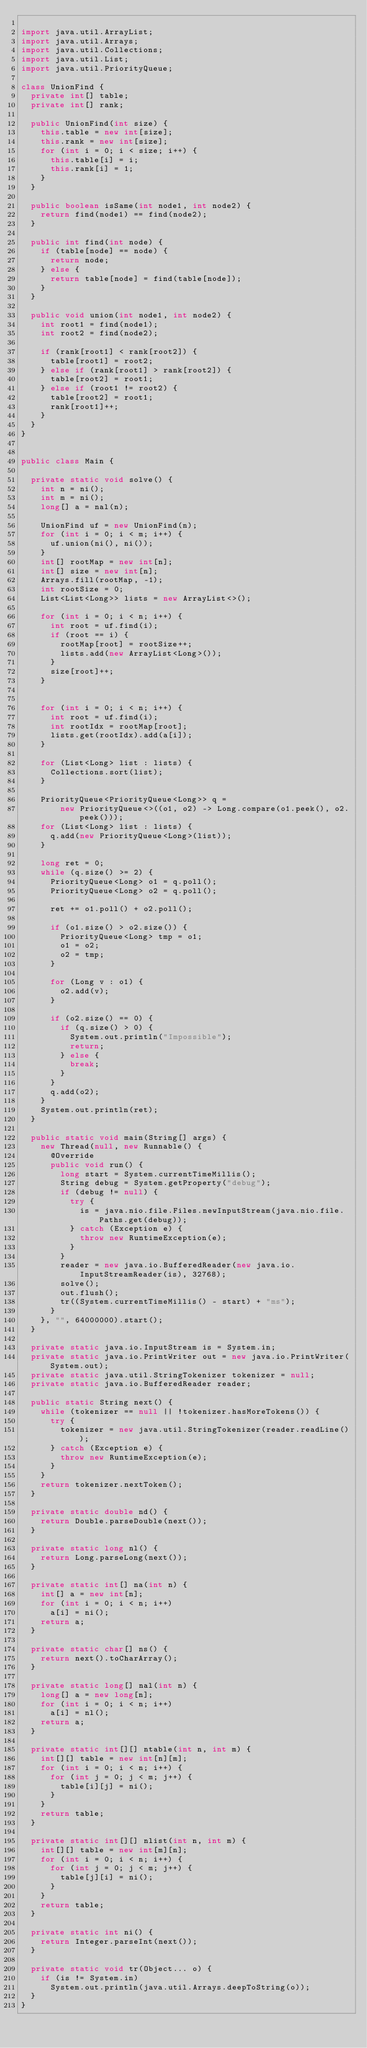<code> <loc_0><loc_0><loc_500><loc_500><_Java_>
import java.util.ArrayList;
import java.util.Arrays;
import java.util.Collections;
import java.util.List;
import java.util.PriorityQueue;

class UnionFind {
  private int[] table;
  private int[] rank;

  public UnionFind(int size) {
    this.table = new int[size];
    this.rank = new int[size];
    for (int i = 0; i < size; i++) {
      this.table[i] = i;
      this.rank[i] = 1;
    }
  }

  public boolean isSame(int node1, int node2) {
    return find(node1) == find(node2);
  }

  public int find(int node) {
    if (table[node] == node) {
      return node;
    } else {
      return table[node] = find(table[node]);
    }
  }

  public void union(int node1, int node2) {
    int root1 = find(node1);
    int root2 = find(node2);

    if (rank[root1] < rank[root2]) {
      table[root1] = root2;
    } else if (rank[root1] > rank[root2]) {
      table[root2] = root1;
    } else if (root1 != root2) {
      table[root2] = root1;
      rank[root1]++;
    }
  }
}


public class Main {

  private static void solve() {
    int n = ni();
    int m = ni();
    long[] a = nal(n);

    UnionFind uf = new UnionFind(n);
    for (int i = 0; i < m; i++) {
      uf.union(ni(), ni());
    }
    int[] rootMap = new int[n];
    int[] size = new int[n];
    Arrays.fill(rootMap, -1);
    int rootSize = 0;
    List<List<Long>> lists = new ArrayList<>();

    for (int i = 0; i < n; i++) {
      int root = uf.find(i);
      if (root == i) {
        rootMap[root] = rootSize++;
        lists.add(new ArrayList<Long>());
      }
      size[root]++;
    }


    for (int i = 0; i < n; i++) {
      int root = uf.find(i);
      int rootIdx = rootMap[root];
      lists.get(rootIdx).add(a[i]);
    }

    for (List<Long> list : lists) {
      Collections.sort(list);
    }

    PriorityQueue<PriorityQueue<Long>> q =
        new PriorityQueue<>((o1, o2) -> Long.compare(o1.peek(), o2.peek()));
    for (List<Long> list : lists) {
      q.add(new PriorityQueue<Long>(list));
    }
    
    long ret = 0;
    while (q.size() >= 2) {
      PriorityQueue<Long> o1 = q.poll();
      PriorityQueue<Long> o2 = q.poll();
      
      ret += o1.poll() + o2.poll();
      
      if (o1.size() > o2.size()) {
        PriorityQueue<Long> tmp = o1;
        o1 = o2;
        o2 = tmp;
      }

      for (Long v : o1) {
        o2.add(v);
      }
      
      if (o2.size() == 0) {
        if (q.size() > 0) {
          System.out.println("Impossible");
          return;
        } else {
          break;
        }
      }
      q.add(o2);
    }
    System.out.println(ret);
  }

  public static void main(String[] args) {
    new Thread(null, new Runnable() {
      @Override
      public void run() {
        long start = System.currentTimeMillis();
        String debug = System.getProperty("debug");
        if (debug != null) {
          try {
            is = java.nio.file.Files.newInputStream(java.nio.file.Paths.get(debug));
          } catch (Exception e) {
            throw new RuntimeException(e);
          }
        }
        reader = new java.io.BufferedReader(new java.io.InputStreamReader(is), 32768);
        solve();
        out.flush();
        tr((System.currentTimeMillis() - start) + "ms");
      }
    }, "", 64000000).start();
  }

  private static java.io.InputStream is = System.in;
  private static java.io.PrintWriter out = new java.io.PrintWriter(System.out);
  private static java.util.StringTokenizer tokenizer = null;
  private static java.io.BufferedReader reader;

  public static String next() {
    while (tokenizer == null || !tokenizer.hasMoreTokens()) {
      try {
        tokenizer = new java.util.StringTokenizer(reader.readLine());
      } catch (Exception e) {
        throw new RuntimeException(e);
      }
    }
    return tokenizer.nextToken();
  }

  private static double nd() {
    return Double.parseDouble(next());
  }

  private static long nl() {
    return Long.parseLong(next());
  }

  private static int[] na(int n) {
    int[] a = new int[n];
    for (int i = 0; i < n; i++)
      a[i] = ni();
    return a;
  }

  private static char[] ns() {
    return next().toCharArray();
  }

  private static long[] nal(int n) {
    long[] a = new long[n];
    for (int i = 0; i < n; i++)
      a[i] = nl();
    return a;
  }

  private static int[][] ntable(int n, int m) {
    int[][] table = new int[n][m];
    for (int i = 0; i < n; i++) {
      for (int j = 0; j < m; j++) {
        table[i][j] = ni();
      }
    }
    return table;
  }

  private static int[][] nlist(int n, int m) {
    int[][] table = new int[m][n];
    for (int i = 0; i < n; i++) {
      for (int j = 0; j < m; j++) {
        table[j][i] = ni();
      }
    }
    return table;
  }

  private static int ni() {
    return Integer.parseInt(next());
  }

  private static void tr(Object... o) {
    if (is != System.in)
      System.out.println(java.util.Arrays.deepToString(o));
  }
}
</code> 